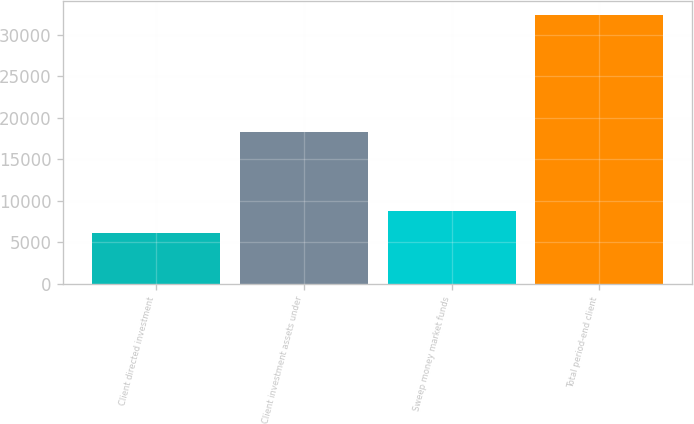Convert chart. <chart><loc_0><loc_0><loc_500><loc_500><bar_chart><fcel>Client directed investment<fcel>Client investment assets under<fcel>Sweep money market funds<fcel>Total period-end client<nl><fcel>6158<fcel>18253<fcel>8779<fcel>32368<nl></chart> 